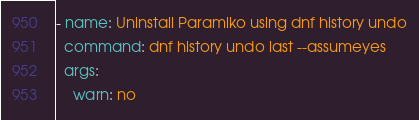Convert code to text. <code><loc_0><loc_0><loc_500><loc_500><_YAML_>- name: Uninstall Paramiko using dnf history undo
  command: dnf history undo last --assumeyes
  args:
    warn: no
</code> 